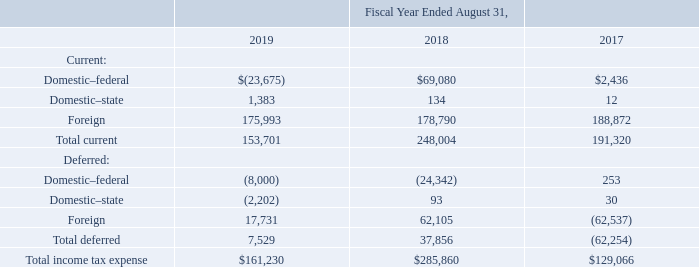4. Income Taxes
Provision for Income Taxes
Income tax expense (benefit) is summarized below (in thousands):
What was the current domestic-federal income tax expense (benefit) in 2017?
Answer scale should be: thousand. $2,436. What was the current domestic-state income tax expense (benefit) in 2019?
Answer scale should be: thousand. 1,383. What years does the table provide information for the company's income tax expense (benefit) for? 2019, 2018, 2017. What is the change in the company's domestic-state income tax expense (benefit) between 2018 and 2019?
Answer scale should be: thousand. 1,383-134
Answer: 1249. What was the change in the company's total current income tax expense (benefit) between 2017 and 2018?
Answer scale should be: thousand. 248,004-191,320
Answer: 56684. What was the percentage change in the total income tax expense between 2018 and 2019?
Answer scale should be: percent. ($161,230-$285,860)/$285,860
Answer: -43.6. 